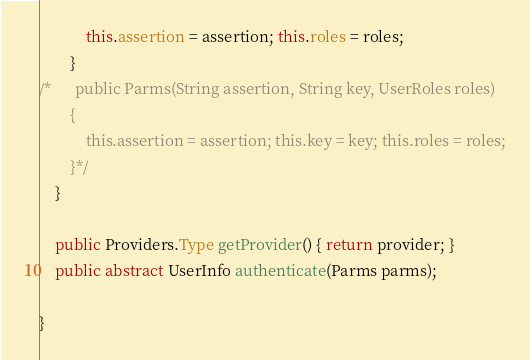Convert code to text. <code><loc_0><loc_0><loc_500><loc_500><_Java_>			this.assertion = assertion; this.roles = roles;
		}
/*		public Parms(String assertion, String key, UserRoles roles)
		{
			this.assertion = assertion; this.key = key; this.roles = roles;
		}*/
	}

	public Providers.Type getProvider() { return provider; }
	public abstract UserInfo authenticate(Parms parms);

}
</code> 